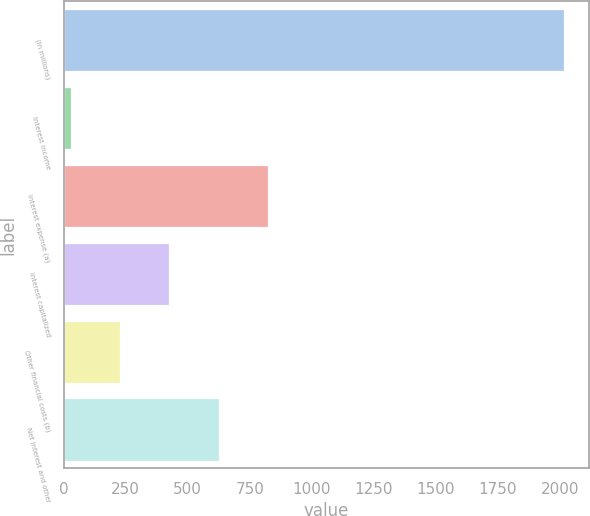<chart> <loc_0><loc_0><loc_500><loc_500><bar_chart><fcel>(In millions)<fcel>Interest income<fcel>Interest expense (a)<fcel>Interest capitalized<fcel>Other financial costs (b)<fcel>Net interest and other<nl><fcel>2017<fcel>27<fcel>824<fcel>425<fcel>226<fcel>625<nl></chart> 